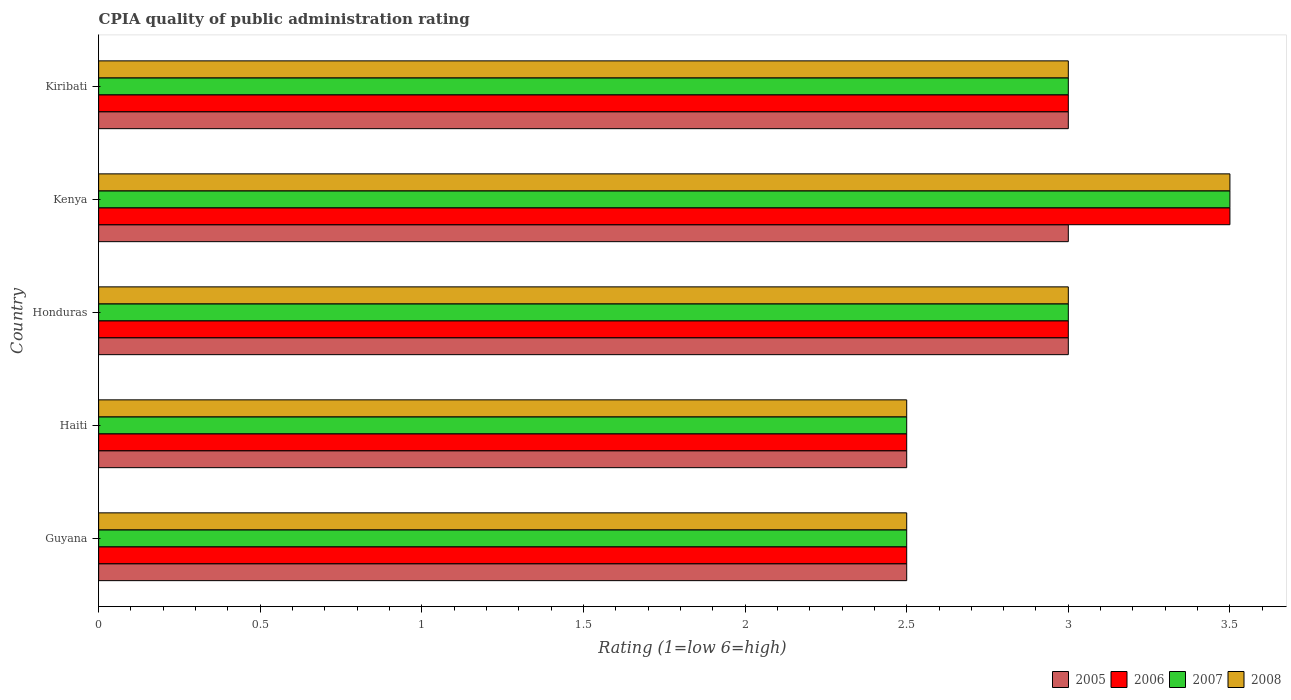How many different coloured bars are there?
Your answer should be very brief. 4. How many groups of bars are there?
Provide a succinct answer. 5. Are the number of bars on each tick of the Y-axis equal?
Your answer should be compact. Yes. How many bars are there on the 3rd tick from the top?
Your answer should be compact. 4. How many bars are there on the 5th tick from the bottom?
Offer a terse response. 4. What is the label of the 2nd group of bars from the top?
Provide a short and direct response. Kenya. In how many cases, is the number of bars for a given country not equal to the number of legend labels?
Your answer should be very brief. 0. What is the CPIA rating in 2006 in Guyana?
Offer a terse response. 2.5. Across all countries, what is the maximum CPIA rating in 2006?
Make the answer very short. 3.5. Across all countries, what is the minimum CPIA rating in 2006?
Offer a very short reply. 2.5. In which country was the CPIA rating in 2007 maximum?
Offer a very short reply. Kenya. In which country was the CPIA rating in 2007 minimum?
Your response must be concise. Guyana. What is the difference between the CPIA rating in 2008 in Haiti and that in Honduras?
Your response must be concise. -0.5. What is the average CPIA rating in 2007 per country?
Provide a short and direct response. 2.9. What is the difference between the CPIA rating in 2005 and CPIA rating in 2006 in Guyana?
Offer a terse response. 0. What is the ratio of the CPIA rating in 2006 in Haiti to that in Kiribati?
Ensure brevity in your answer.  0.83. Is the CPIA rating in 2005 in Guyana less than that in Kiribati?
Give a very brief answer. Yes. Is the difference between the CPIA rating in 2005 in Honduras and Kiribati greater than the difference between the CPIA rating in 2006 in Honduras and Kiribati?
Provide a succinct answer. No. What does the 4th bar from the top in Honduras represents?
Give a very brief answer. 2005. What does the 2nd bar from the bottom in Kenya represents?
Your answer should be very brief. 2006. How many bars are there?
Offer a terse response. 20. How many countries are there in the graph?
Make the answer very short. 5. Are the values on the major ticks of X-axis written in scientific E-notation?
Make the answer very short. No. Where does the legend appear in the graph?
Your answer should be very brief. Bottom right. How many legend labels are there?
Offer a terse response. 4. What is the title of the graph?
Your answer should be very brief. CPIA quality of public administration rating. What is the label or title of the X-axis?
Provide a short and direct response. Rating (1=low 6=high). What is the label or title of the Y-axis?
Your answer should be compact. Country. What is the Rating (1=low 6=high) of 2008 in Guyana?
Ensure brevity in your answer.  2.5. What is the Rating (1=low 6=high) in 2005 in Haiti?
Provide a succinct answer. 2.5. What is the Rating (1=low 6=high) of 2007 in Haiti?
Ensure brevity in your answer.  2.5. What is the Rating (1=low 6=high) in 2005 in Honduras?
Give a very brief answer. 3. What is the Rating (1=low 6=high) in 2008 in Honduras?
Offer a very short reply. 3. What is the Rating (1=low 6=high) of 2005 in Kenya?
Ensure brevity in your answer.  3. What is the Rating (1=low 6=high) in 2008 in Kenya?
Offer a terse response. 3.5. What is the Rating (1=low 6=high) of 2006 in Kiribati?
Provide a succinct answer. 3. What is the Rating (1=low 6=high) of 2007 in Kiribati?
Keep it short and to the point. 3. Across all countries, what is the maximum Rating (1=low 6=high) of 2005?
Provide a short and direct response. 3. Across all countries, what is the maximum Rating (1=low 6=high) in 2006?
Provide a succinct answer. 3.5. Across all countries, what is the maximum Rating (1=low 6=high) in 2008?
Offer a terse response. 3.5. Across all countries, what is the minimum Rating (1=low 6=high) in 2007?
Your answer should be compact. 2.5. Across all countries, what is the minimum Rating (1=low 6=high) of 2008?
Give a very brief answer. 2.5. What is the total Rating (1=low 6=high) in 2006 in the graph?
Provide a short and direct response. 14.5. What is the difference between the Rating (1=low 6=high) of 2005 in Guyana and that in Haiti?
Provide a succinct answer. 0. What is the difference between the Rating (1=low 6=high) of 2007 in Guyana and that in Haiti?
Offer a very short reply. 0. What is the difference between the Rating (1=low 6=high) in 2005 in Guyana and that in Honduras?
Ensure brevity in your answer.  -0.5. What is the difference between the Rating (1=low 6=high) in 2006 in Guyana and that in Honduras?
Keep it short and to the point. -0.5. What is the difference between the Rating (1=low 6=high) in 2008 in Guyana and that in Honduras?
Give a very brief answer. -0.5. What is the difference between the Rating (1=low 6=high) of 2005 in Guyana and that in Kenya?
Your answer should be very brief. -0.5. What is the difference between the Rating (1=low 6=high) of 2006 in Guyana and that in Kenya?
Provide a succinct answer. -1. What is the difference between the Rating (1=low 6=high) in 2005 in Guyana and that in Kiribati?
Your response must be concise. -0.5. What is the difference between the Rating (1=low 6=high) in 2006 in Guyana and that in Kiribati?
Your response must be concise. -0.5. What is the difference between the Rating (1=low 6=high) in 2006 in Haiti and that in Honduras?
Your answer should be very brief. -0.5. What is the difference between the Rating (1=low 6=high) in 2008 in Haiti and that in Honduras?
Your answer should be compact. -0.5. What is the difference between the Rating (1=low 6=high) of 2005 in Haiti and that in Kiribati?
Make the answer very short. -0.5. What is the difference between the Rating (1=low 6=high) in 2007 in Haiti and that in Kiribati?
Give a very brief answer. -0.5. What is the difference between the Rating (1=low 6=high) in 2008 in Haiti and that in Kiribati?
Your answer should be very brief. -0.5. What is the difference between the Rating (1=low 6=high) in 2005 in Honduras and that in Kenya?
Your answer should be compact. 0. What is the difference between the Rating (1=low 6=high) of 2006 in Honduras and that in Kenya?
Your response must be concise. -0.5. What is the difference between the Rating (1=low 6=high) in 2007 in Honduras and that in Kenya?
Offer a very short reply. -0.5. What is the difference between the Rating (1=low 6=high) in 2005 in Kenya and that in Kiribati?
Ensure brevity in your answer.  0. What is the difference between the Rating (1=low 6=high) in 2006 in Kenya and that in Kiribati?
Your answer should be very brief. 0.5. What is the difference between the Rating (1=low 6=high) of 2007 in Kenya and that in Kiribati?
Keep it short and to the point. 0.5. What is the difference between the Rating (1=low 6=high) of 2005 in Guyana and the Rating (1=low 6=high) of 2006 in Haiti?
Keep it short and to the point. 0. What is the difference between the Rating (1=low 6=high) of 2005 in Guyana and the Rating (1=low 6=high) of 2007 in Haiti?
Make the answer very short. 0. What is the difference between the Rating (1=low 6=high) of 2006 in Guyana and the Rating (1=low 6=high) of 2007 in Honduras?
Make the answer very short. -0.5. What is the difference between the Rating (1=low 6=high) in 2006 in Guyana and the Rating (1=low 6=high) in 2008 in Honduras?
Your response must be concise. -0.5. What is the difference between the Rating (1=low 6=high) in 2007 in Guyana and the Rating (1=low 6=high) in 2008 in Honduras?
Your response must be concise. -0.5. What is the difference between the Rating (1=low 6=high) in 2005 in Guyana and the Rating (1=low 6=high) in 2006 in Kenya?
Provide a short and direct response. -1. What is the difference between the Rating (1=low 6=high) of 2005 in Guyana and the Rating (1=low 6=high) of 2008 in Kenya?
Offer a terse response. -1. What is the difference between the Rating (1=low 6=high) in 2007 in Guyana and the Rating (1=low 6=high) in 2008 in Kenya?
Provide a succinct answer. -1. What is the difference between the Rating (1=low 6=high) in 2005 in Guyana and the Rating (1=low 6=high) in 2006 in Kiribati?
Provide a succinct answer. -0.5. What is the difference between the Rating (1=low 6=high) of 2005 in Guyana and the Rating (1=low 6=high) of 2008 in Kiribati?
Your response must be concise. -0.5. What is the difference between the Rating (1=low 6=high) of 2006 in Guyana and the Rating (1=low 6=high) of 2007 in Kiribati?
Your response must be concise. -0.5. What is the difference between the Rating (1=low 6=high) in 2006 in Guyana and the Rating (1=low 6=high) in 2008 in Kiribati?
Keep it short and to the point. -0.5. What is the difference between the Rating (1=low 6=high) in 2007 in Guyana and the Rating (1=low 6=high) in 2008 in Kiribati?
Give a very brief answer. -0.5. What is the difference between the Rating (1=low 6=high) of 2005 in Haiti and the Rating (1=low 6=high) of 2008 in Honduras?
Give a very brief answer. -0.5. What is the difference between the Rating (1=low 6=high) of 2006 in Haiti and the Rating (1=low 6=high) of 2007 in Honduras?
Your answer should be compact. -0.5. What is the difference between the Rating (1=low 6=high) in 2007 in Haiti and the Rating (1=low 6=high) in 2008 in Honduras?
Keep it short and to the point. -0.5. What is the difference between the Rating (1=low 6=high) of 2005 in Haiti and the Rating (1=low 6=high) of 2007 in Kenya?
Keep it short and to the point. -1. What is the difference between the Rating (1=low 6=high) of 2005 in Haiti and the Rating (1=low 6=high) of 2008 in Kenya?
Your answer should be compact. -1. What is the difference between the Rating (1=low 6=high) of 2006 in Haiti and the Rating (1=low 6=high) of 2007 in Kenya?
Provide a succinct answer. -1. What is the difference between the Rating (1=low 6=high) of 2005 in Haiti and the Rating (1=low 6=high) of 2006 in Kiribati?
Offer a very short reply. -0.5. What is the difference between the Rating (1=low 6=high) in 2005 in Haiti and the Rating (1=low 6=high) in 2008 in Kiribati?
Make the answer very short. -0.5. What is the difference between the Rating (1=low 6=high) of 2006 in Haiti and the Rating (1=low 6=high) of 2007 in Kiribati?
Offer a very short reply. -0.5. What is the difference between the Rating (1=low 6=high) in 2006 in Haiti and the Rating (1=low 6=high) in 2008 in Kiribati?
Provide a short and direct response. -0.5. What is the difference between the Rating (1=low 6=high) in 2005 in Honduras and the Rating (1=low 6=high) in 2006 in Kenya?
Ensure brevity in your answer.  -0.5. What is the difference between the Rating (1=low 6=high) of 2005 in Honduras and the Rating (1=low 6=high) of 2007 in Kenya?
Your response must be concise. -0.5. What is the difference between the Rating (1=low 6=high) in 2006 in Honduras and the Rating (1=low 6=high) in 2007 in Kenya?
Your answer should be very brief. -0.5. What is the difference between the Rating (1=low 6=high) in 2006 in Honduras and the Rating (1=low 6=high) in 2008 in Kenya?
Ensure brevity in your answer.  -0.5. What is the difference between the Rating (1=low 6=high) in 2007 in Honduras and the Rating (1=low 6=high) in 2008 in Kenya?
Keep it short and to the point. -0.5. What is the difference between the Rating (1=low 6=high) in 2005 in Honduras and the Rating (1=low 6=high) in 2006 in Kiribati?
Make the answer very short. 0. What is the difference between the Rating (1=low 6=high) of 2005 in Honduras and the Rating (1=low 6=high) of 2008 in Kiribati?
Offer a terse response. 0. What is the difference between the Rating (1=low 6=high) of 2006 in Honduras and the Rating (1=low 6=high) of 2007 in Kiribati?
Offer a very short reply. 0. What is the difference between the Rating (1=low 6=high) in 2007 in Honduras and the Rating (1=low 6=high) in 2008 in Kiribati?
Keep it short and to the point. 0. What is the difference between the Rating (1=low 6=high) of 2007 in Kenya and the Rating (1=low 6=high) of 2008 in Kiribati?
Offer a terse response. 0.5. What is the average Rating (1=low 6=high) in 2006 per country?
Your response must be concise. 2.9. What is the difference between the Rating (1=low 6=high) of 2005 and Rating (1=low 6=high) of 2007 in Guyana?
Your answer should be compact. 0. What is the difference between the Rating (1=low 6=high) of 2006 and Rating (1=low 6=high) of 2008 in Guyana?
Keep it short and to the point. 0. What is the difference between the Rating (1=low 6=high) of 2007 and Rating (1=low 6=high) of 2008 in Guyana?
Provide a succinct answer. 0. What is the difference between the Rating (1=low 6=high) of 2005 and Rating (1=low 6=high) of 2007 in Haiti?
Offer a terse response. 0. What is the difference between the Rating (1=low 6=high) in 2006 and Rating (1=low 6=high) in 2007 in Haiti?
Keep it short and to the point. 0. What is the difference between the Rating (1=low 6=high) in 2006 and Rating (1=low 6=high) in 2008 in Haiti?
Give a very brief answer. 0. What is the difference between the Rating (1=low 6=high) in 2007 and Rating (1=low 6=high) in 2008 in Haiti?
Ensure brevity in your answer.  0. What is the difference between the Rating (1=low 6=high) of 2005 and Rating (1=low 6=high) of 2006 in Honduras?
Offer a terse response. 0. What is the difference between the Rating (1=low 6=high) of 2005 and Rating (1=low 6=high) of 2007 in Honduras?
Your answer should be compact. 0. What is the difference between the Rating (1=low 6=high) of 2005 and Rating (1=low 6=high) of 2008 in Honduras?
Provide a short and direct response. 0. What is the difference between the Rating (1=low 6=high) in 2006 and Rating (1=low 6=high) in 2007 in Honduras?
Ensure brevity in your answer.  0. What is the difference between the Rating (1=low 6=high) of 2006 and Rating (1=low 6=high) of 2008 in Honduras?
Keep it short and to the point. 0. What is the difference between the Rating (1=low 6=high) of 2005 and Rating (1=low 6=high) of 2006 in Kenya?
Keep it short and to the point. -0.5. What is the difference between the Rating (1=low 6=high) of 2005 and Rating (1=low 6=high) of 2007 in Kenya?
Provide a short and direct response. -0.5. What is the difference between the Rating (1=low 6=high) of 2006 and Rating (1=low 6=high) of 2007 in Kenya?
Provide a short and direct response. 0. What is the difference between the Rating (1=low 6=high) in 2006 and Rating (1=low 6=high) in 2008 in Kenya?
Your answer should be very brief. 0. What is the difference between the Rating (1=low 6=high) in 2007 and Rating (1=low 6=high) in 2008 in Kenya?
Provide a succinct answer. 0. What is the difference between the Rating (1=low 6=high) of 2005 and Rating (1=low 6=high) of 2006 in Kiribati?
Ensure brevity in your answer.  0. What is the difference between the Rating (1=low 6=high) in 2005 and Rating (1=low 6=high) in 2008 in Kiribati?
Your answer should be very brief. 0. What is the difference between the Rating (1=low 6=high) of 2006 and Rating (1=low 6=high) of 2008 in Kiribati?
Provide a short and direct response. 0. What is the difference between the Rating (1=low 6=high) of 2007 and Rating (1=low 6=high) of 2008 in Kiribati?
Your answer should be compact. 0. What is the ratio of the Rating (1=low 6=high) in 2005 in Guyana to that in Haiti?
Keep it short and to the point. 1. What is the ratio of the Rating (1=low 6=high) of 2006 in Guyana to that in Haiti?
Your answer should be compact. 1. What is the ratio of the Rating (1=low 6=high) of 2006 in Guyana to that in Honduras?
Provide a short and direct response. 0.83. What is the ratio of the Rating (1=low 6=high) of 2008 in Guyana to that in Honduras?
Your response must be concise. 0.83. What is the ratio of the Rating (1=low 6=high) of 2006 in Guyana to that in Kenya?
Make the answer very short. 0.71. What is the ratio of the Rating (1=low 6=high) of 2005 in Guyana to that in Kiribati?
Provide a short and direct response. 0.83. What is the ratio of the Rating (1=low 6=high) in 2006 in Guyana to that in Kiribati?
Make the answer very short. 0.83. What is the ratio of the Rating (1=low 6=high) of 2007 in Guyana to that in Kiribati?
Make the answer very short. 0.83. What is the ratio of the Rating (1=low 6=high) in 2005 in Haiti to that in Honduras?
Offer a very short reply. 0.83. What is the ratio of the Rating (1=low 6=high) of 2008 in Haiti to that in Honduras?
Give a very brief answer. 0.83. What is the ratio of the Rating (1=low 6=high) in 2007 in Haiti to that in Kenya?
Ensure brevity in your answer.  0.71. What is the ratio of the Rating (1=low 6=high) of 2005 in Haiti to that in Kiribati?
Your response must be concise. 0.83. What is the ratio of the Rating (1=low 6=high) in 2006 in Haiti to that in Kiribati?
Offer a terse response. 0.83. What is the ratio of the Rating (1=low 6=high) in 2007 in Haiti to that in Kiribati?
Your answer should be compact. 0.83. What is the ratio of the Rating (1=low 6=high) of 2007 in Honduras to that in Kenya?
Give a very brief answer. 0.86. What is the ratio of the Rating (1=low 6=high) in 2005 in Honduras to that in Kiribati?
Offer a very short reply. 1. What is the ratio of the Rating (1=low 6=high) of 2006 in Honduras to that in Kiribati?
Make the answer very short. 1. What is the ratio of the Rating (1=low 6=high) of 2005 in Kenya to that in Kiribati?
Provide a short and direct response. 1. What is the ratio of the Rating (1=low 6=high) in 2007 in Kenya to that in Kiribati?
Make the answer very short. 1.17. What is the difference between the highest and the second highest Rating (1=low 6=high) in 2006?
Ensure brevity in your answer.  0.5. What is the difference between the highest and the second highest Rating (1=low 6=high) of 2007?
Give a very brief answer. 0.5. What is the difference between the highest and the lowest Rating (1=low 6=high) of 2005?
Give a very brief answer. 0.5. 